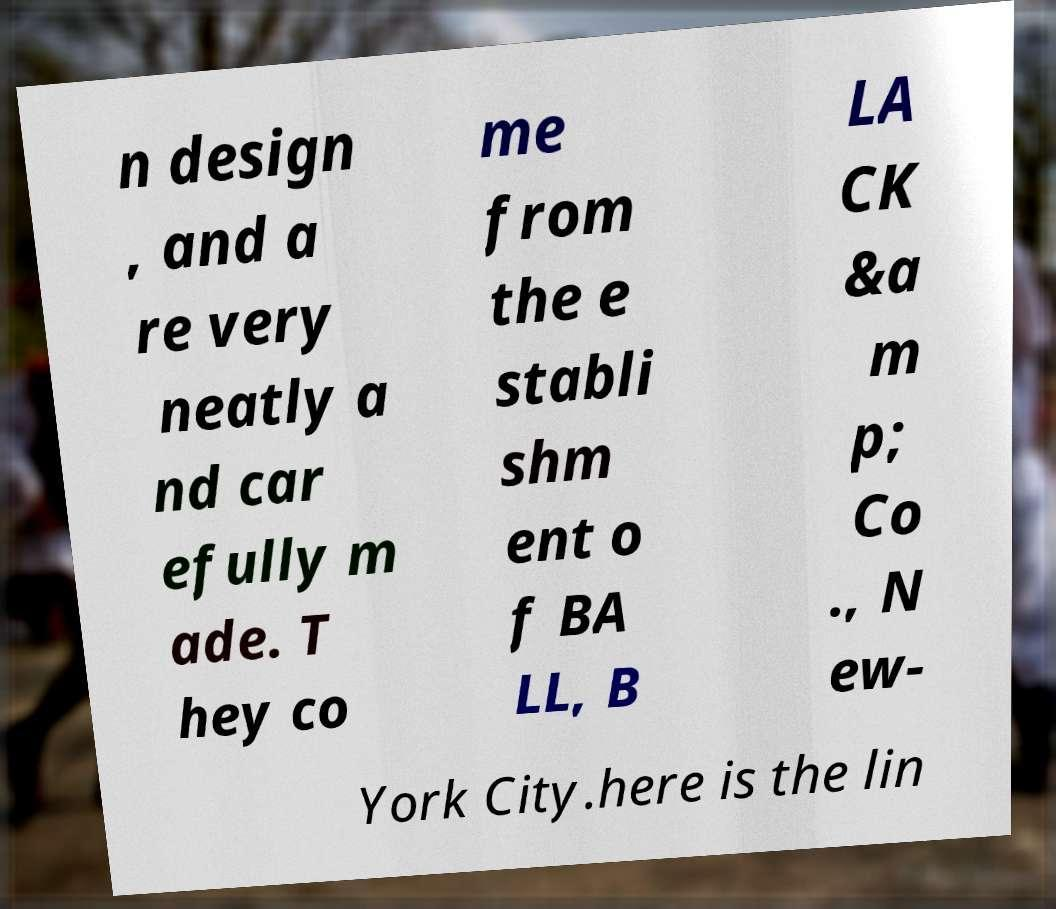I need the written content from this picture converted into text. Can you do that? n design , and a re very neatly a nd car efully m ade. T hey co me from the e stabli shm ent o f BA LL, B LA CK &a m p; Co ., N ew- York City.here is the lin 